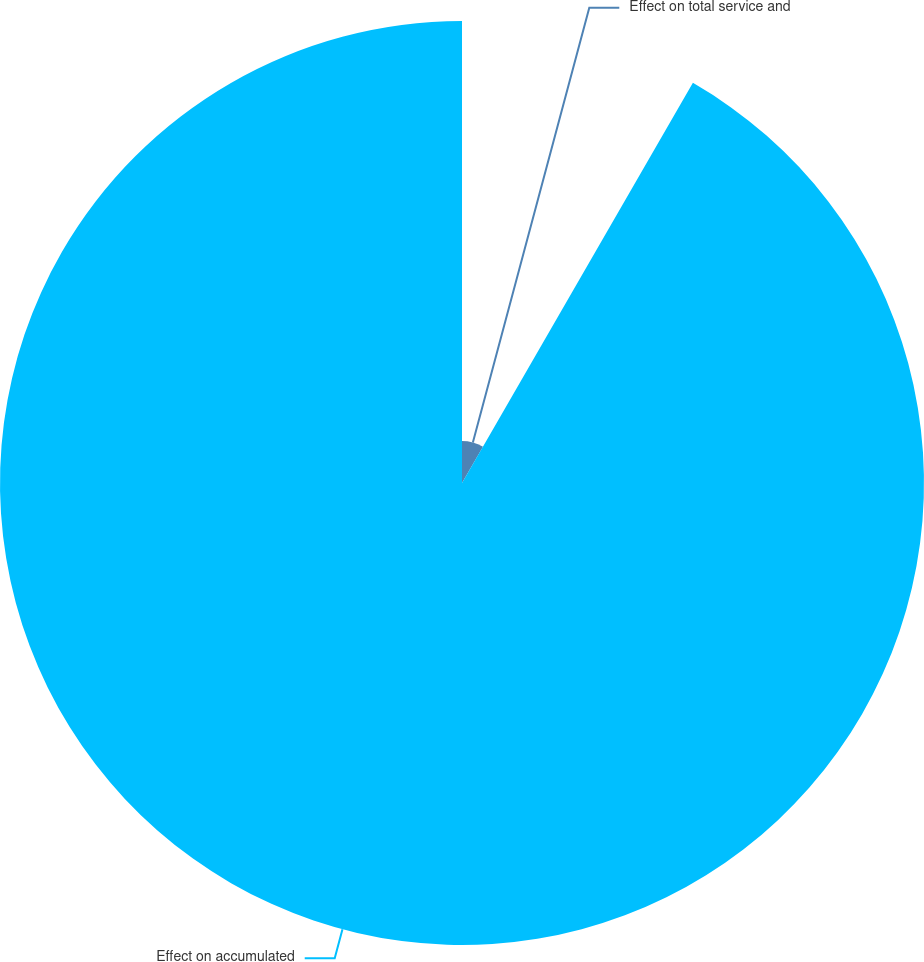<chart> <loc_0><loc_0><loc_500><loc_500><pie_chart><fcel>Effect on total service and<fcel>Effect on accumulated<nl><fcel>8.33%<fcel>91.67%<nl></chart> 